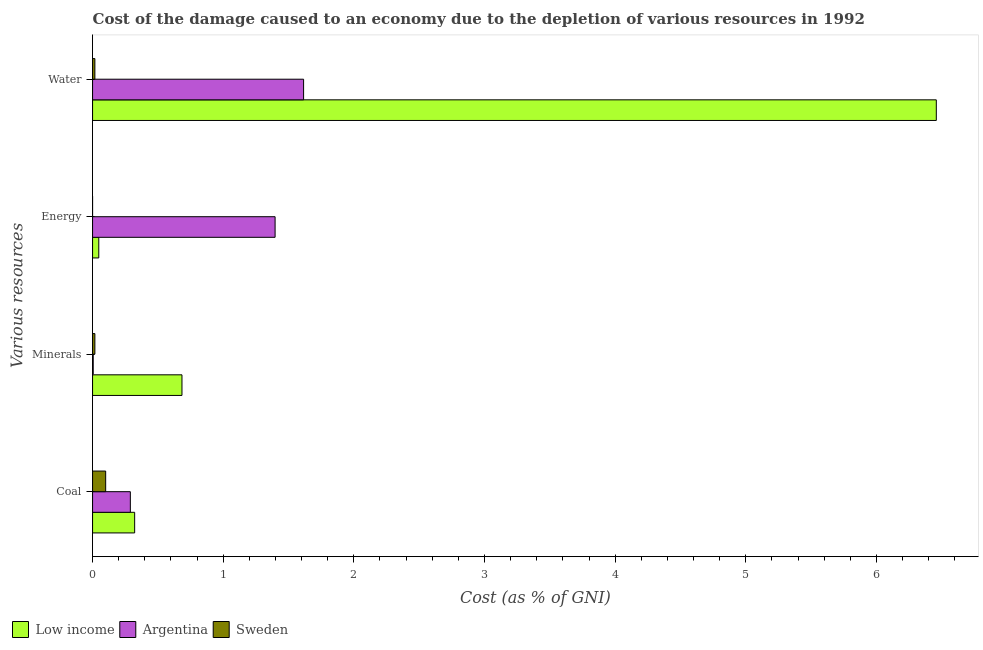How many different coloured bars are there?
Your answer should be very brief. 3. Are the number of bars per tick equal to the number of legend labels?
Your answer should be very brief. Yes. Are the number of bars on each tick of the Y-axis equal?
Your answer should be compact. Yes. How many bars are there on the 2nd tick from the bottom?
Your response must be concise. 3. What is the label of the 1st group of bars from the top?
Your answer should be very brief. Water. What is the cost of damage due to depletion of coal in Sweden?
Offer a terse response. 0.1. Across all countries, what is the maximum cost of damage due to depletion of water?
Provide a succinct answer. 6.46. Across all countries, what is the minimum cost of damage due to depletion of coal?
Your response must be concise. 0.1. In which country was the cost of damage due to depletion of energy maximum?
Offer a very short reply. Argentina. What is the total cost of damage due to depletion of water in the graph?
Keep it short and to the point. 8.09. What is the difference between the cost of damage due to depletion of coal in Argentina and that in Sweden?
Your answer should be very brief. 0.19. What is the difference between the cost of damage due to depletion of water in Sweden and the cost of damage due to depletion of coal in Argentina?
Provide a succinct answer. -0.27. What is the average cost of damage due to depletion of energy per country?
Ensure brevity in your answer.  0.48. What is the difference between the cost of damage due to depletion of water and cost of damage due to depletion of coal in Low income?
Ensure brevity in your answer.  6.14. In how many countries, is the cost of damage due to depletion of minerals greater than 4.8 %?
Offer a terse response. 0. What is the ratio of the cost of damage due to depletion of energy in Low income to that in Argentina?
Offer a very short reply. 0.03. Is the cost of damage due to depletion of water in Sweden less than that in Low income?
Offer a very short reply. Yes. Is the difference between the cost of damage due to depletion of water in Low income and Sweden greater than the difference between the cost of damage due to depletion of energy in Low income and Sweden?
Your response must be concise. Yes. What is the difference between the highest and the second highest cost of damage due to depletion of water?
Provide a short and direct response. 4.84. What is the difference between the highest and the lowest cost of damage due to depletion of coal?
Offer a very short reply. 0.22. In how many countries, is the cost of damage due to depletion of coal greater than the average cost of damage due to depletion of coal taken over all countries?
Make the answer very short. 2. How many bars are there?
Keep it short and to the point. 12. Are all the bars in the graph horizontal?
Make the answer very short. Yes. How many countries are there in the graph?
Offer a very short reply. 3. What is the difference between two consecutive major ticks on the X-axis?
Keep it short and to the point. 1. Does the graph contain any zero values?
Your response must be concise. No. What is the title of the graph?
Give a very brief answer. Cost of the damage caused to an economy due to the depletion of various resources in 1992 . Does "Qatar" appear as one of the legend labels in the graph?
Your answer should be compact. No. What is the label or title of the X-axis?
Keep it short and to the point. Cost (as % of GNI). What is the label or title of the Y-axis?
Your answer should be compact. Various resources. What is the Cost (as % of GNI) in Low income in Coal?
Keep it short and to the point. 0.32. What is the Cost (as % of GNI) in Argentina in Coal?
Keep it short and to the point. 0.29. What is the Cost (as % of GNI) in Sweden in Coal?
Keep it short and to the point. 0.1. What is the Cost (as % of GNI) of Low income in Minerals?
Provide a succinct answer. 0.68. What is the Cost (as % of GNI) in Argentina in Minerals?
Provide a succinct answer. 0. What is the Cost (as % of GNI) of Sweden in Minerals?
Your answer should be compact. 0.02. What is the Cost (as % of GNI) of Low income in Energy?
Offer a terse response. 0.05. What is the Cost (as % of GNI) of Argentina in Energy?
Offer a very short reply. 1.4. What is the Cost (as % of GNI) in Sweden in Energy?
Your response must be concise. 2.46812414981984e-5. What is the Cost (as % of GNI) of Low income in Water?
Your answer should be very brief. 6.46. What is the Cost (as % of GNI) in Argentina in Water?
Give a very brief answer. 1.62. What is the Cost (as % of GNI) of Sweden in Water?
Offer a very short reply. 0.02. Across all Various resources, what is the maximum Cost (as % of GNI) in Low income?
Ensure brevity in your answer.  6.46. Across all Various resources, what is the maximum Cost (as % of GNI) in Argentina?
Provide a short and direct response. 1.62. Across all Various resources, what is the maximum Cost (as % of GNI) in Sweden?
Your response must be concise. 0.1. Across all Various resources, what is the minimum Cost (as % of GNI) of Low income?
Give a very brief answer. 0.05. Across all Various resources, what is the minimum Cost (as % of GNI) of Argentina?
Give a very brief answer. 0. Across all Various resources, what is the minimum Cost (as % of GNI) of Sweden?
Make the answer very short. 2.46812414981984e-5. What is the total Cost (as % of GNI) in Low income in the graph?
Your answer should be compact. 7.51. What is the total Cost (as % of GNI) of Argentina in the graph?
Your answer should be compact. 3.31. What is the total Cost (as % of GNI) in Sweden in the graph?
Offer a terse response. 0.14. What is the difference between the Cost (as % of GNI) of Low income in Coal and that in Minerals?
Provide a short and direct response. -0.36. What is the difference between the Cost (as % of GNI) in Argentina in Coal and that in Minerals?
Offer a terse response. 0.28. What is the difference between the Cost (as % of GNI) in Sweden in Coal and that in Minerals?
Your answer should be very brief. 0.08. What is the difference between the Cost (as % of GNI) in Low income in Coal and that in Energy?
Your answer should be very brief. 0.27. What is the difference between the Cost (as % of GNI) in Argentina in Coal and that in Energy?
Your response must be concise. -1.11. What is the difference between the Cost (as % of GNI) of Sweden in Coal and that in Energy?
Make the answer very short. 0.1. What is the difference between the Cost (as % of GNI) of Low income in Coal and that in Water?
Your answer should be very brief. -6.14. What is the difference between the Cost (as % of GNI) of Argentina in Coal and that in Water?
Give a very brief answer. -1.33. What is the difference between the Cost (as % of GNI) in Sweden in Coal and that in Water?
Your response must be concise. 0.08. What is the difference between the Cost (as % of GNI) in Low income in Minerals and that in Energy?
Your answer should be compact. 0.64. What is the difference between the Cost (as % of GNI) of Argentina in Minerals and that in Energy?
Ensure brevity in your answer.  -1.39. What is the difference between the Cost (as % of GNI) in Sweden in Minerals and that in Energy?
Give a very brief answer. 0.02. What is the difference between the Cost (as % of GNI) of Low income in Minerals and that in Water?
Provide a succinct answer. -5.77. What is the difference between the Cost (as % of GNI) in Argentina in Minerals and that in Water?
Your response must be concise. -1.61. What is the difference between the Cost (as % of GNI) of Low income in Energy and that in Water?
Offer a very short reply. -6.41. What is the difference between the Cost (as % of GNI) of Argentina in Energy and that in Water?
Give a very brief answer. -0.22. What is the difference between the Cost (as % of GNI) in Sweden in Energy and that in Water?
Provide a short and direct response. -0.02. What is the difference between the Cost (as % of GNI) in Low income in Coal and the Cost (as % of GNI) in Argentina in Minerals?
Your response must be concise. 0.32. What is the difference between the Cost (as % of GNI) of Low income in Coal and the Cost (as % of GNI) of Sweden in Minerals?
Keep it short and to the point. 0.3. What is the difference between the Cost (as % of GNI) of Argentina in Coal and the Cost (as % of GNI) of Sweden in Minerals?
Provide a short and direct response. 0.27. What is the difference between the Cost (as % of GNI) in Low income in Coal and the Cost (as % of GNI) in Argentina in Energy?
Offer a terse response. -1.08. What is the difference between the Cost (as % of GNI) in Low income in Coal and the Cost (as % of GNI) in Sweden in Energy?
Your answer should be compact. 0.32. What is the difference between the Cost (as % of GNI) of Argentina in Coal and the Cost (as % of GNI) of Sweden in Energy?
Give a very brief answer. 0.29. What is the difference between the Cost (as % of GNI) in Low income in Coal and the Cost (as % of GNI) in Argentina in Water?
Give a very brief answer. -1.29. What is the difference between the Cost (as % of GNI) of Low income in Coal and the Cost (as % of GNI) of Sweden in Water?
Offer a terse response. 0.3. What is the difference between the Cost (as % of GNI) in Argentina in Coal and the Cost (as % of GNI) in Sweden in Water?
Offer a very short reply. 0.27. What is the difference between the Cost (as % of GNI) of Low income in Minerals and the Cost (as % of GNI) of Argentina in Energy?
Your answer should be compact. -0.71. What is the difference between the Cost (as % of GNI) of Low income in Minerals and the Cost (as % of GNI) of Sweden in Energy?
Make the answer very short. 0.68. What is the difference between the Cost (as % of GNI) of Argentina in Minerals and the Cost (as % of GNI) of Sweden in Energy?
Your answer should be compact. 0. What is the difference between the Cost (as % of GNI) of Low income in Minerals and the Cost (as % of GNI) of Argentina in Water?
Your answer should be compact. -0.93. What is the difference between the Cost (as % of GNI) in Low income in Minerals and the Cost (as % of GNI) in Sweden in Water?
Your answer should be compact. 0.67. What is the difference between the Cost (as % of GNI) of Argentina in Minerals and the Cost (as % of GNI) of Sweden in Water?
Offer a terse response. -0.01. What is the difference between the Cost (as % of GNI) of Low income in Energy and the Cost (as % of GNI) of Argentina in Water?
Provide a succinct answer. -1.57. What is the difference between the Cost (as % of GNI) in Low income in Energy and the Cost (as % of GNI) in Sweden in Water?
Ensure brevity in your answer.  0.03. What is the difference between the Cost (as % of GNI) in Argentina in Energy and the Cost (as % of GNI) in Sweden in Water?
Provide a short and direct response. 1.38. What is the average Cost (as % of GNI) of Low income per Various resources?
Offer a very short reply. 1.88. What is the average Cost (as % of GNI) in Argentina per Various resources?
Offer a terse response. 0.83. What is the average Cost (as % of GNI) of Sweden per Various resources?
Provide a succinct answer. 0.03. What is the difference between the Cost (as % of GNI) of Low income and Cost (as % of GNI) of Argentina in Coal?
Your answer should be very brief. 0.03. What is the difference between the Cost (as % of GNI) in Low income and Cost (as % of GNI) in Sweden in Coal?
Make the answer very short. 0.22. What is the difference between the Cost (as % of GNI) of Argentina and Cost (as % of GNI) of Sweden in Coal?
Make the answer very short. 0.19. What is the difference between the Cost (as % of GNI) in Low income and Cost (as % of GNI) in Argentina in Minerals?
Your response must be concise. 0.68. What is the difference between the Cost (as % of GNI) in Low income and Cost (as % of GNI) in Sweden in Minerals?
Your answer should be very brief. 0.67. What is the difference between the Cost (as % of GNI) in Argentina and Cost (as % of GNI) in Sweden in Minerals?
Offer a very short reply. -0.01. What is the difference between the Cost (as % of GNI) of Low income and Cost (as % of GNI) of Argentina in Energy?
Your answer should be compact. -1.35. What is the difference between the Cost (as % of GNI) of Low income and Cost (as % of GNI) of Sweden in Energy?
Your response must be concise. 0.05. What is the difference between the Cost (as % of GNI) of Argentina and Cost (as % of GNI) of Sweden in Energy?
Your answer should be very brief. 1.4. What is the difference between the Cost (as % of GNI) of Low income and Cost (as % of GNI) of Argentina in Water?
Offer a very short reply. 4.84. What is the difference between the Cost (as % of GNI) in Low income and Cost (as % of GNI) in Sweden in Water?
Provide a succinct answer. 6.44. What is the difference between the Cost (as % of GNI) in Argentina and Cost (as % of GNI) in Sweden in Water?
Offer a terse response. 1.6. What is the ratio of the Cost (as % of GNI) of Low income in Coal to that in Minerals?
Your answer should be compact. 0.47. What is the ratio of the Cost (as % of GNI) of Argentina in Coal to that in Minerals?
Make the answer very short. 58.46. What is the ratio of the Cost (as % of GNI) of Sweden in Coal to that in Minerals?
Offer a terse response. 5.67. What is the ratio of the Cost (as % of GNI) of Low income in Coal to that in Energy?
Your response must be concise. 6.78. What is the ratio of the Cost (as % of GNI) in Argentina in Coal to that in Energy?
Offer a terse response. 0.21. What is the ratio of the Cost (as % of GNI) of Sweden in Coal to that in Energy?
Offer a terse response. 4062.21. What is the ratio of the Cost (as % of GNI) of Low income in Coal to that in Water?
Make the answer very short. 0.05. What is the ratio of the Cost (as % of GNI) of Argentina in Coal to that in Water?
Make the answer very short. 0.18. What is the ratio of the Cost (as % of GNI) of Sweden in Coal to that in Water?
Your answer should be very brief. 5.66. What is the ratio of the Cost (as % of GNI) of Low income in Minerals to that in Energy?
Your answer should be compact. 14.4. What is the ratio of the Cost (as % of GNI) in Argentina in Minerals to that in Energy?
Offer a terse response. 0. What is the ratio of the Cost (as % of GNI) in Sweden in Minerals to that in Energy?
Keep it short and to the point. 716.92. What is the ratio of the Cost (as % of GNI) in Low income in Minerals to that in Water?
Your answer should be very brief. 0.11. What is the ratio of the Cost (as % of GNI) in Argentina in Minerals to that in Water?
Offer a very short reply. 0. What is the ratio of the Cost (as % of GNI) in Low income in Energy to that in Water?
Provide a short and direct response. 0.01. What is the ratio of the Cost (as % of GNI) of Argentina in Energy to that in Water?
Provide a succinct answer. 0.86. What is the ratio of the Cost (as % of GNI) in Sweden in Energy to that in Water?
Ensure brevity in your answer.  0. What is the difference between the highest and the second highest Cost (as % of GNI) of Low income?
Provide a short and direct response. 5.77. What is the difference between the highest and the second highest Cost (as % of GNI) in Argentina?
Your answer should be very brief. 0.22. What is the difference between the highest and the second highest Cost (as % of GNI) in Sweden?
Offer a terse response. 0.08. What is the difference between the highest and the lowest Cost (as % of GNI) of Low income?
Provide a short and direct response. 6.41. What is the difference between the highest and the lowest Cost (as % of GNI) of Argentina?
Make the answer very short. 1.61. What is the difference between the highest and the lowest Cost (as % of GNI) in Sweden?
Your answer should be compact. 0.1. 